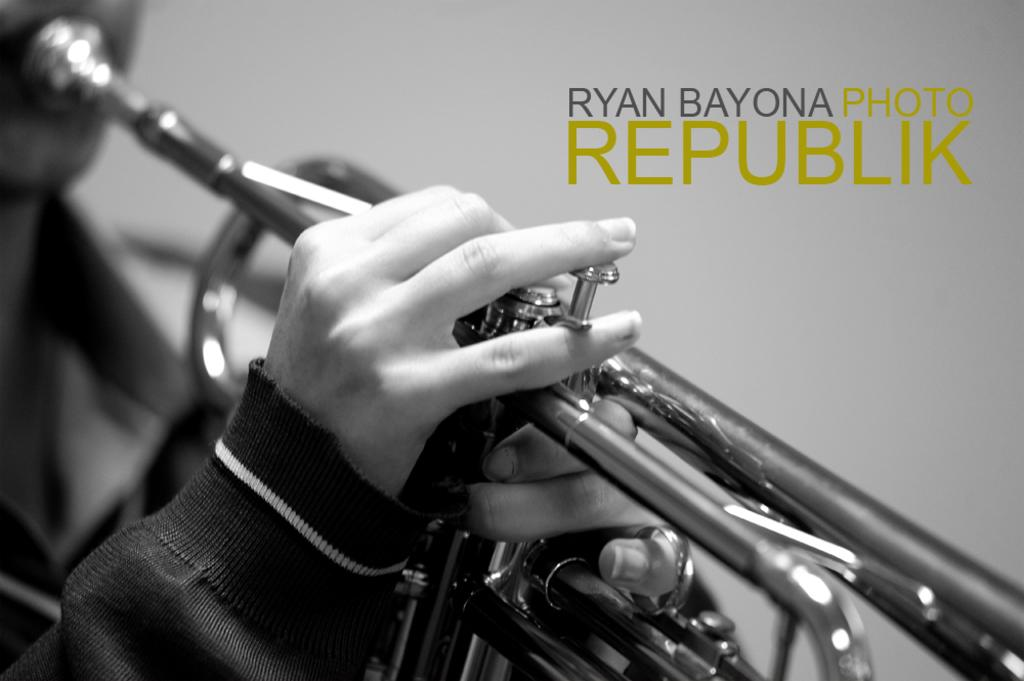What is the main subject of the image? There is a person playing a musical instrument in the image. What can be observed about the background of the image? The background of the image is grey. Where is the text located in the image? The text is on the right side of the image. What type of lead can be seen in the image? There is no lead present in the image. What is happening to the ground in the image? There is no ground visible in the image; it is focused on the person playing the musical instrument and the text on the right side. 